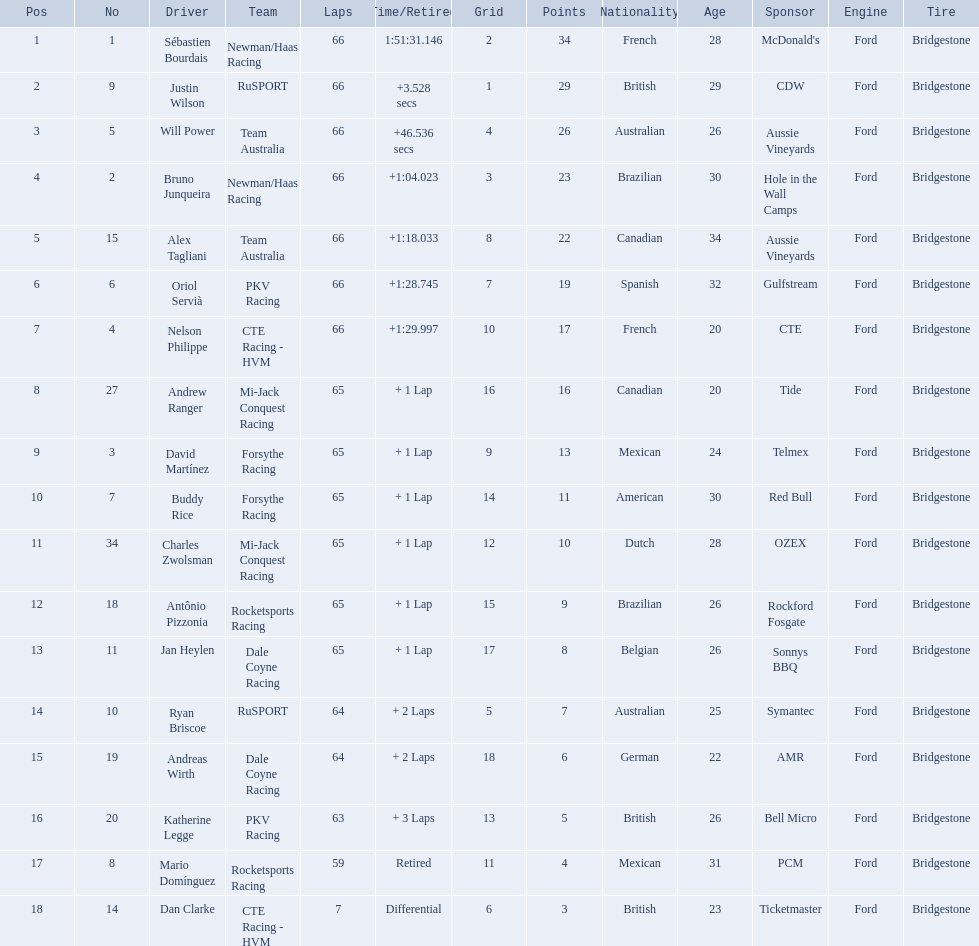Which teams participated in the 2006 gran premio telmex? Newman/Haas Racing, RuSPORT, Team Australia, Newman/Haas Racing, Team Australia, PKV Racing, CTE Racing - HVM, Mi-Jack Conquest Racing, Forsythe Racing, Forsythe Racing, Mi-Jack Conquest Racing, Rocketsports Racing, Dale Coyne Racing, RuSPORT, Dale Coyne Racing, PKV Racing, Rocketsports Racing, CTE Racing - HVM. Who were the drivers of these teams? Sébastien Bourdais, Justin Wilson, Will Power, Bruno Junqueira, Alex Tagliani, Oriol Servià, Nelson Philippe, Andrew Ranger, David Martínez, Buddy Rice, Charles Zwolsman, Antônio Pizzonia, Jan Heylen, Ryan Briscoe, Andreas Wirth, Katherine Legge, Mario Domínguez, Dan Clarke. Which driver finished last? Dan Clarke. 